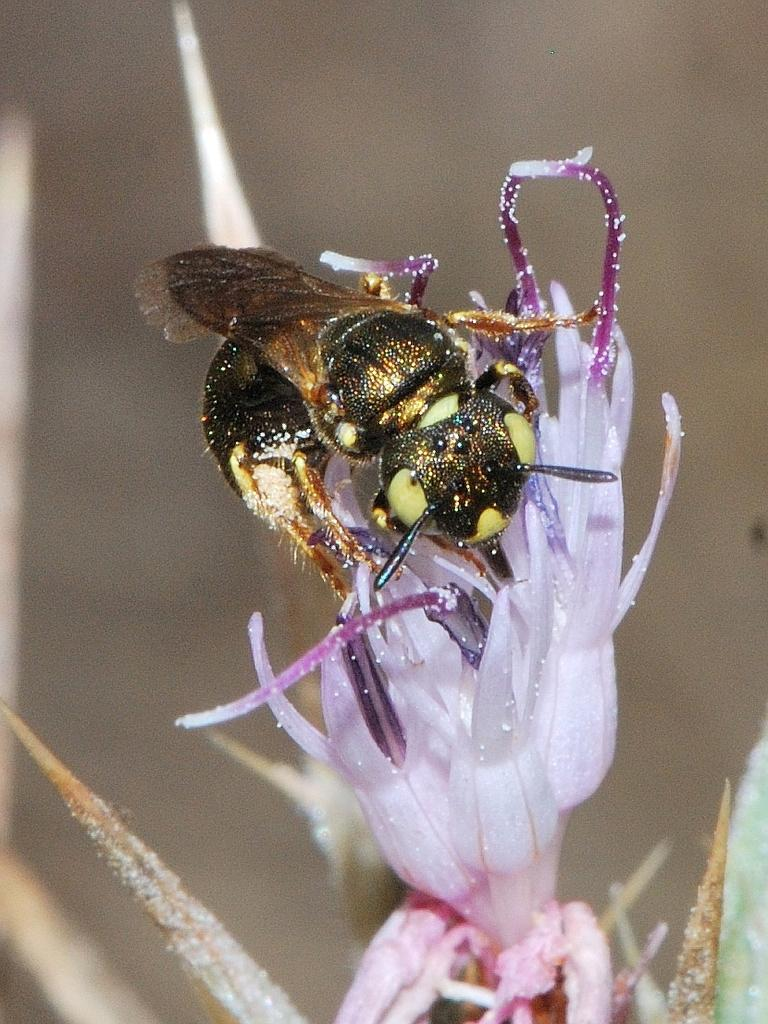What type of insect is in the image? There is a honey bee in the image. What colors can be seen on the honey bee? The honey bee is brown and yellow in color. What is the honey bee sitting on in the image? The honey bee is sitting on a purple flower. How would you describe the background of the image? The background of the image is blurred. What type of cherries does the mother believe in the image? There are no cherries or references to beliefs in the image; it features a honey bee sitting on a purple flower. 